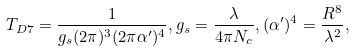Convert formula to latex. <formula><loc_0><loc_0><loc_500><loc_500>T _ { D 7 } = \frac { 1 } { g _ { s } ( 2 \pi ) ^ { 3 } ( 2 \pi \alpha ^ { \prime } ) ^ { 4 } } , g _ { s } = \frac { \lambda } { 4 \pi N _ { c } } , ( \alpha ^ { \prime } ) ^ { 4 } = \frac { R ^ { 8 } } { \lambda ^ { 2 } } ,</formula> 